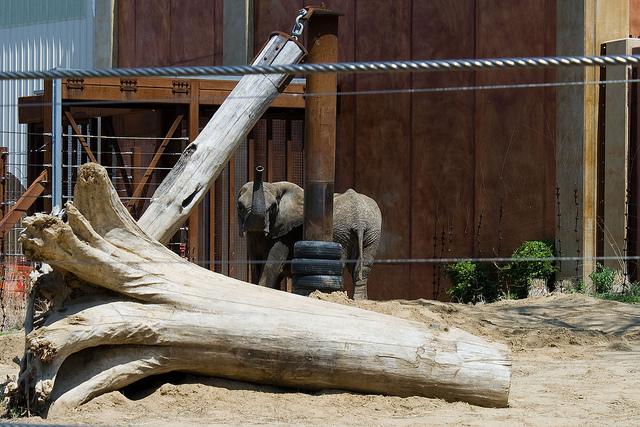What animal is in background?
Write a very short answer. Elephant. What color is the fence?
Quick response, please. Silver. Is this tree branch laying on it's side?
Short answer required. Yes. 